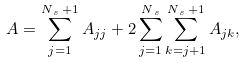<formula> <loc_0><loc_0><loc_500><loc_500>A = \sum _ { j = 1 } ^ { N _ { \, s } \, + 1 } A _ { j j } + 2 \sum _ { j = 1 } ^ { N _ { \, s } } \sum _ { k = j + 1 } ^ { N _ { \, s } \, + 1 } A _ { j k } ,</formula> 